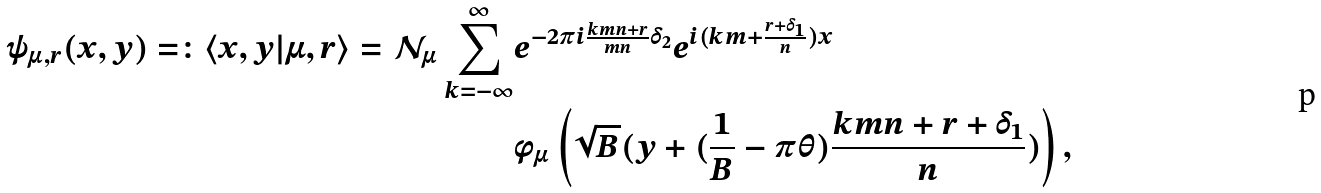<formula> <loc_0><loc_0><loc_500><loc_500>\psi _ { \mu , r } ( x , y ) = \colon \langle x , y | \mu , r \rangle = \mathcal { N } _ { \mu } \sum _ { k = - \infty } ^ { \infty } & e ^ { - 2 \pi i \frac { k m n + r } { m n } \delta _ { 2 } } e ^ { i ( k m + \frac { r + \delta _ { 1 } } { n } ) x } \\ & \phi _ { \mu } \left ( \sqrt { B } ( y + ( \frac { 1 } { B } - \pi \theta ) \frac { k m n + r + \delta _ { 1 } } { n } ) \right ) ,</formula> 